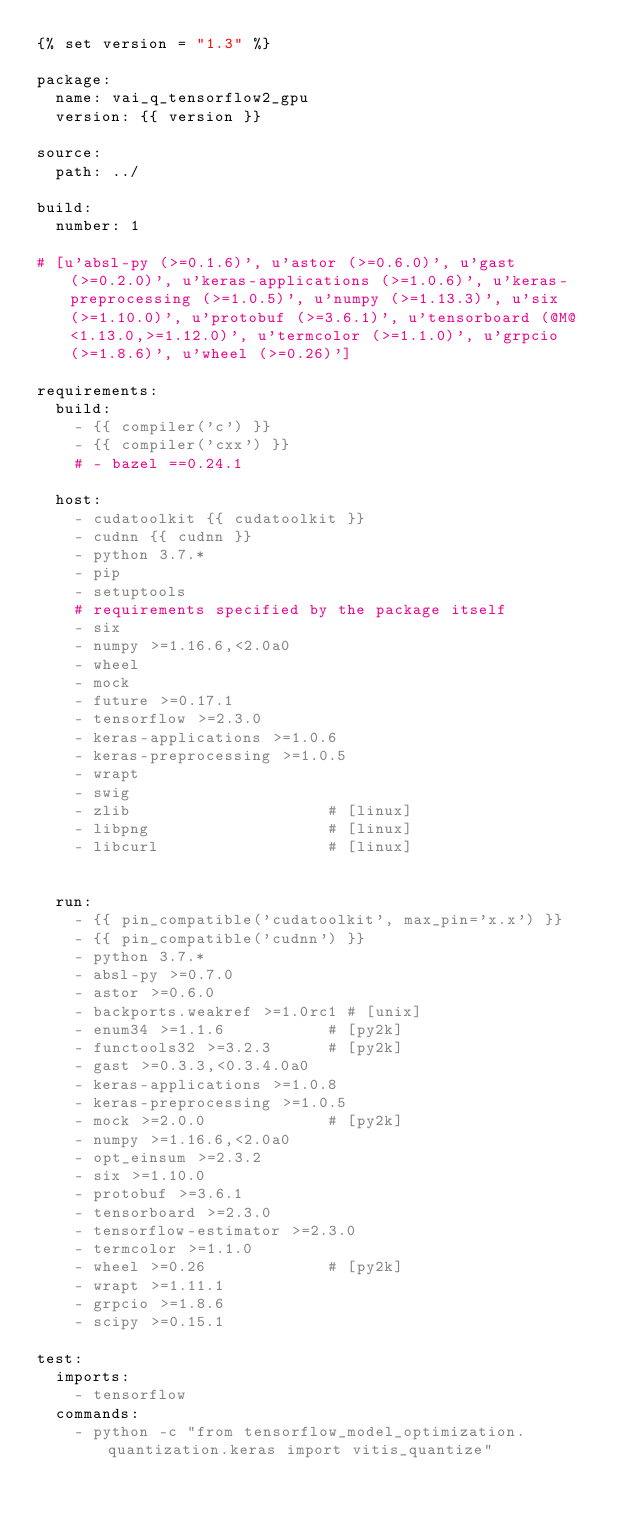Convert code to text. <code><loc_0><loc_0><loc_500><loc_500><_YAML_>{% set version = "1.3" %}

package:
  name: vai_q_tensorflow2_gpu
  version: {{ version }}

source:
  path: ../

build:
  number: 1

# [u'absl-py (>=0.1.6)', u'astor (>=0.6.0)', u'gast (>=0.2.0)', u'keras-applications (>=1.0.6)', u'keras-preprocessing (>=1.0.5)', u'numpy (>=1.13.3)', u'six (>=1.10.0)', u'protobuf (>=3.6.1)', u'tensorboard (@M@<1.13.0,>=1.12.0)', u'termcolor (>=1.1.0)', u'grpcio (>=1.8.6)', u'wheel (>=0.26)']

requirements:
  build:
    - {{ compiler('c') }}
    - {{ compiler('cxx') }}
    # - bazel ==0.24.1

  host:
    - cudatoolkit {{ cudatoolkit }}
    - cudnn {{ cudnn }}
    - python 3.7.*
    - pip
    - setuptools
    # requirements specified by the package itself
    - six
    - numpy >=1.16.6,<2.0a0
    - wheel
    - mock
    - future >=0.17.1
    - tensorflow >=2.3.0
    - keras-applications >=1.0.6
    - keras-preprocessing >=1.0.5
    - wrapt
    - swig
    - zlib                     # [linux]
    - libpng                   # [linux]
    - libcurl                  # [linux]


  run:
    - {{ pin_compatible('cudatoolkit', max_pin='x.x') }}
    - {{ pin_compatible('cudnn') }}
    - python 3.7.*
    - absl-py >=0.7.0
    - astor >=0.6.0
    - backports.weakref >=1.0rc1 # [unix]
    - enum34 >=1.1.6           # [py2k]
    - functools32 >=3.2.3      # [py2k]
    - gast >=0.3.3,<0.3.4.0a0
    - keras-applications >=1.0.8
    - keras-preprocessing >=1.0.5
    - mock >=2.0.0             # [py2k]
    - numpy >=1.16.6,<2.0a0
    - opt_einsum >=2.3.2
    - six >=1.10.0
    - protobuf >=3.6.1
    - tensorboard >=2.3.0
    - tensorflow-estimator >=2.3.0
    - termcolor >=1.1.0
    - wheel >=0.26             # [py2k]
    - wrapt >=1.11.1
    - grpcio >=1.8.6
    - scipy >=0.15.1

test:
  imports:
    - tensorflow
  commands:
    - python -c "from tensorflow_model_optimization.quantization.keras import vitis_quantize"
</code> 